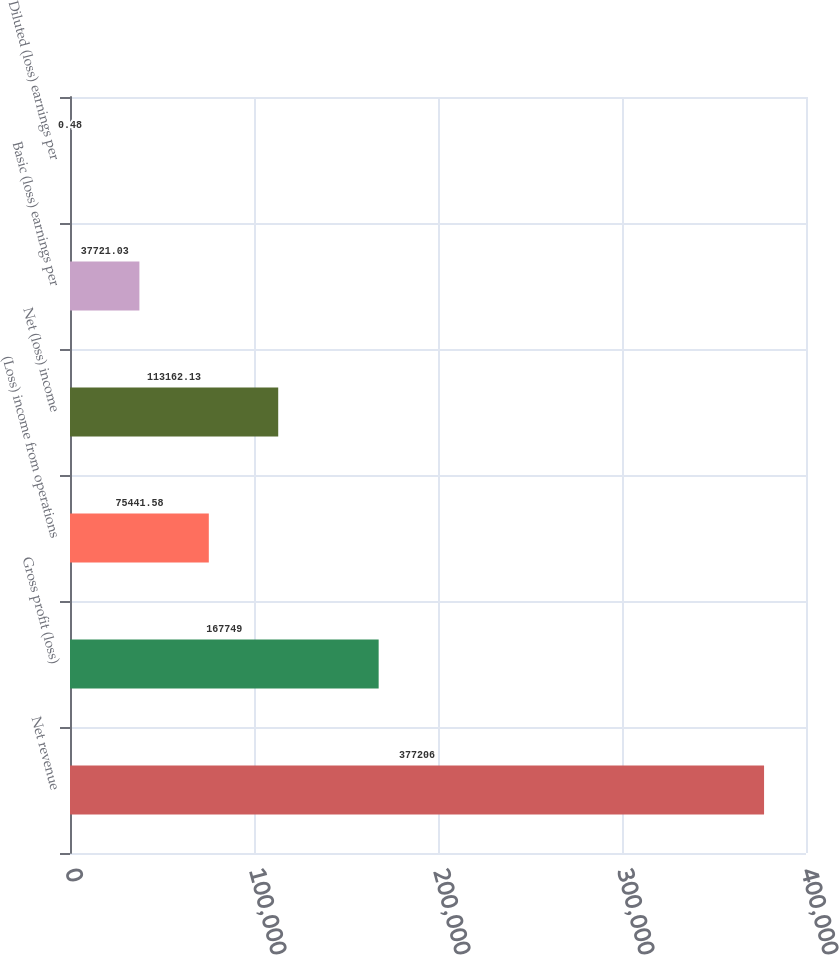<chart> <loc_0><loc_0><loc_500><loc_500><bar_chart><fcel>Net revenue<fcel>Gross profit (loss)<fcel>(Loss) income from operations<fcel>Net (loss) income<fcel>Basic (loss) earnings per<fcel>Diluted (loss) earnings per<nl><fcel>377206<fcel>167749<fcel>75441.6<fcel>113162<fcel>37721<fcel>0.48<nl></chart> 